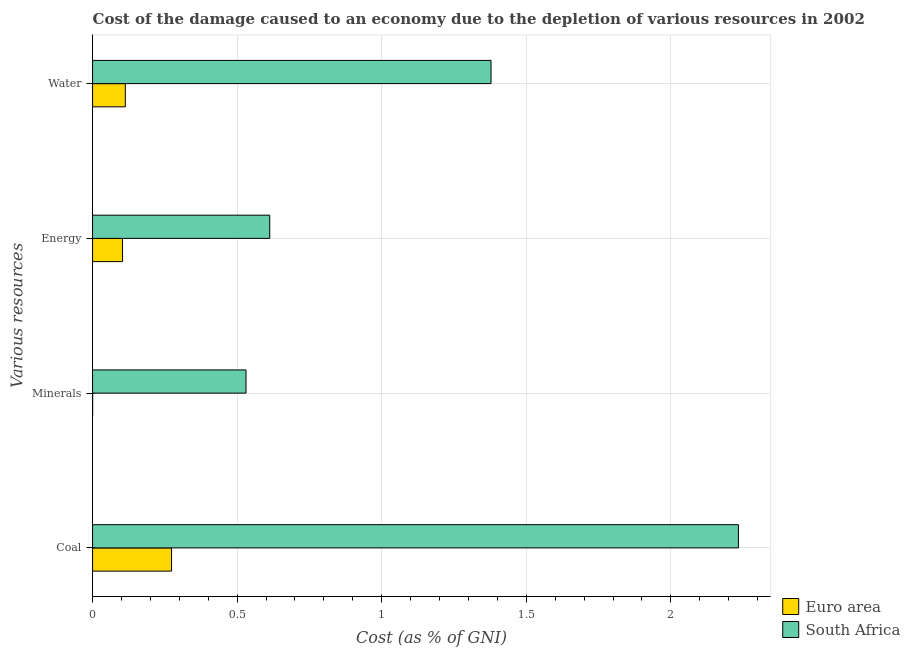How many different coloured bars are there?
Offer a terse response. 2. Are the number of bars per tick equal to the number of legend labels?
Make the answer very short. Yes. How many bars are there on the 2nd tick from the top?
Give a very brief answer. 2. How many bars are there on the 4th tick from the bottom?
Ensure brevity in your answer.  2. What is the label of the 3rd group of bars from the top?
Offer a very short reply. Minerals. What is the cost of damage due to depletion of energy in South Africa?
Ensure brevity in your answer.  0.61. Across all countries, what is the maximum cost of damage due to depletion of energy?
Your response must be concise. 0.61. Across all countries, what is the minimum cost of damage due to depletion of energy?
Offer a terse response. 0.1. In which country was the cost of damage due to depletion of minerals maximum?
Your response must be concise. South Africa. In which country was the cost of damage due to depletion of coal minimum?
Make the answer very short. Euro area. What is the total cost of damage due to depletion of minerals in the graph?
Offer a terse response. 0.53. What is the difference between the cost of damage due to depletion of energy in Euro area and that in South Africa?
Make the answer very short. -0.51. What is the difference between the cost of damage due to depletion of energy in South Africa and the cost of damage due to depletion of minerals in Euro area?
Give a very brief answer. 0.61. What is the average cost of damage due to depletion of minerals per country?
Ensure brevity in your answer.  0.27. What is the difference between the cost of damage due to depletion of water and cost of damage due to depletion of energy in South Africa?
Keep it short and to the point. 0.77. What is the ratio of the cost of damage due to depletion of energy in South Africa to that in Euro area?
Give a very brief answer. 5.91. Is the cost of damage due to depletion of coal in South Africa less than that in Euro area?
Offer a very short reply. No. Is the difference between the cost of damage due to depletion of water in Euro area and South Africa greater than the difference between the cost of damage due to depletion of minerals in Euro area and South Africa?
Keep it short and to the point. No. What is the difference between the highest and the second highest cost of damage due to depletion of minerals?
Your answer should be compact. 0.53. What is the difference between the highest and the lowest cost of damage due to depletion of coal?
Provide a succinct answer. 1.96. Is it the case that in every country, the sum of the cost of damage due to depletion of coal and cost of damage due to depletion of energy is greater than the sum of cost of damage due to depletion of water and cost of damage due to depletion of minerals?
Keep it short and to the point. No. What does the 2nd bar from the top in Water represents?
Ensure brevity in your answer.  Euro area. What does the 2nd bar from the bottom in Coal represents?
Offer a very short reply. South Africa. How many bars are there?
Your answer should be compact. 8. Are all the bars in the graph horizontal?
Provide a short and direct response. Yes. How many countries are there in the graph?
Ensure brevity in your answer.  2. What is the difference between two consecutive major ticks on the X-axis?
Ensure brevity in your answer.  0.5. Are the values on the major ticks of X-axis written in scientific E-notation?
Make the answer very short. No. Does the graph contain any zero values?
Provide a short and direct response. No. Does the graph contain grids?
Give a very brief answer. Yes. What is the title of the graph?
Ensure brevity in your answer.  Cost of the damage caused to an economy due to the depletion of various resources in 2002 . Does "Turks and Caicos Islands" appear as one of the legend labels in the graph?
Your response must be concise. No. What is the label or title of the X-axis?
Offer a very short reply. Cost (as % of GNI). What is the label or title of the Y-axis?
Provide a short and direct response. Various resources. What is the Cost (as % of GNI) of Euro area in Coal?
Offer a very short reply. 0.27. What is the Cost (as % of GNI) in South Africa in Coal?
Give a very brief answer. 2.23. What is the Cost (as % of GNI) in Euro area in Minerals?
Ensure brevity in your answer.  0. What is the Cost (as % of GNI) of South Africa in Minerals?
Your answer should be compact. 0.53. What is the Cost (as % of GNI) of Euro area in Energy?
Ensure brevity in your answer.  0.1. What is the Cost (as % of GNI) of South Africa in Energy?
Offer a terse response. 0.61. What is the Cost (as % of GNI) in Euro area in Water?
Keep it short and to the point. 0.11. What is the Cost (as % of GNI) in South Africa in Water?
Make the answer very short. 1.38. Across all Various resources, what is the maximum Cost (as % of GNI) of Euro area?
Make the answer very short. 0.27. Across all Various resources, what is the maximum Cost (as % of GNI) in South Africa?
Offer a very short reply. 2.23. Across all Various resources, what is the minimum Cost (as % of GNI) in Euro area?
Your answer should be very brief. 0. Across all Various resources, what is the minimum Cost (as % of GNI) in South Africa?
Offer a terse response. 0.53. What is the total Cost (as % of GNI) of Euro area in the graph?
Provide a succinct answer. 0.49. What is the total Cost (as % of GNI) of South Africa in the graph?
Make the answer very short. 4.76. What is the difference between the Cost (as % of GNI) in Euro area in Coal and that in Minerals?
Provide a succinct answer. 0.27. What is the difference between the Cost (as % of GNI) of South Africa in Coal and that in Minerals?
Your response must be concise. 1.7. What is the difference between the Cost (as % of GNI) in Euro area in Coal and that in Energy?
Give a very brief answer. 0.17. What is the difference between the Cost (as % of GNI) of South Africa in Coal and that in Energy?
Make the answer very short. 1.62. What is the difference between the Cost (as % of GNI) of Euro area in Coal and that in Water?
Keep it short and to the point. 0.16. What is the difference between the Cost (as % of GNI) of South Africa in Coal and that in Water?
Provide a succinct answer. 0.86. What is the difference between the Cost (as % of GNI) in Euro area in Minerals and that in Energy?
Offer a very short reply. -0.1. What is the difference between the Cost (as % of GNI) of South Africa in Minerals and that in Energy?
Provide a succinct answer. -0.08. What is the difference between the Cost (as % of GNI) of Euro area in Minerals and that in Water?
Your answer should be very brief. -0.11. What is the difference between the Cost (as % of GNI) of South Africa in Minerals and that in Water?
Offer a terse response. -0.85. What is the difference between the Cost (as % of GNI) in Euro area in Energy and that in Water?
Your answer should be compact. -0.01. What is the difference between the Cost (as % of GNI) in South Africa in Energy and that in Water?
Provide a short and direct response. -0.77. What is the difference between the Cost (as % of GNI) in Euro area in Coal and the Cost (as % of GNI) in South Africa in Minerals?
Provide a short and direct response. -0.26. What is the difference between the Cost (as % of GNI) of Euro area in Coal and the Cost (as % of GNI) of South Africa in Energy?
Provide a short and direct response. -0.34. What is the difference between the Cost (as % of GNI) in Euro area in Coal and the Cost (as % of GNI) in South Africa in Water?
Offer a very short reply. -1.1. What is the difference between the Cost (as % of GNI) in Euro area in Minerals and the Cost (as % of GNI) in South Africa in Energy?
Your answer should be compact. -0.61. What is the difference between the Cost (as % of GNI) of Euro area in Minerals and the Cost (as % of GNI) of South Africa in Water?
Give a very brief answer. -1.38. What is the difference between the Cost (as % of GNI) in Euro area in Energy and the Cost (as % of GNI) in South Africa in Water?
Keep it short and to the point. -1.27. What is the average Cost (as % of GNI) of Euro area per Various resources?
Offer a terse response. 0.12. What is the average Cost (as % of GNI) in South Africa per Various resources?
Your response must be concise. 1.19. What is the difference between the Cost (as % of GNI) of Euro area and Cost (as % of GNI) of South Africa in Coal?
Your answer should be very brief. -1.96. What is the difference between the Cost (as % of GNI) of Euro area and Cost (as % of GNI) of South Africa in Minerals?
Ensure brevity in your answer.  -0.53. What is the difference between the Cost (as % of GNI) in Euro area and Cost (as % of GNI) in South Africa in Energy?
Make the answer very short. -0.51. What is the difference between the Cost (as % of GNI) in Euro area and Cost (as % of GNI) in South Africa in Water?
Make the answer very short. -1.26. What is the ratio of the Cost (as % of GNI) in Euro area in Coal to that in Minerals?
Keep it short and to the point. 1127.12. What is the ratio of the Cost (as % of GNI) of South Africa in Coal to that in Minerals?
Provide a short and direct response. 4.21. What is the ratio of the Cost (as % of GNI) of Euro area in Coal to that in Energy?
Ensure brevity in your answer.  2.63. What is the ratio of the Cost (as % of GNI) of South Africa in Coal to that in Energy?
Give a very brief answer. 3.65. What is the ratio of the Cost (as % of GNI) of Euro area in Coal to that in Water?
Provide a short and direct response. 2.41. What is the ratio of the Cost (as % of GNI) of South Africa in Coal to that in Water?
Offer a terse response. 1.62. What is the ratio of the Cost (as % of GNI) in Euro area in Minerals to that in Energy?
Offer a very short reply. 0. What is the ratio of the Cost (as % of GNI) of South Africa in Minerals to that in Energy?
Your response must be concise. 0.87. What is the ratio of the Cost (as % of GNI) in Euro area in Minerals to that in Water?
Your answer should be compact. 0. What is the ratio of the Cost (as % of GNI) of South Africa in Minerals to that in Water?
Keep it short and to the point. 0.39. What is the ratio of the Cost (as % of GNI) in Euro area in Energy to that in Water?
Your answer should be very brief. 0.91. What is the ratio of the Cost (as % of GNI) of South Africa in Energy to that in Water?
Your answer should be very brief. 0.44. What is the difference between the highest and the second highest Cost (as % of GNI) of Euro area?
Provide a short and direct response. 0.16. What is the difference between the highest and the second highest Cost (as % of GNI) in South Africa?
Provide a succinct answer. 0.86. What is the difference between the highest and the lowest Cost (as % of GNI) in Euro area?
Offer a very short reply. 0.27. What is the difference between the highest and the lowest Cost (as % of GNI) in South Africa?
Your answer should be very brief. 1.7. 